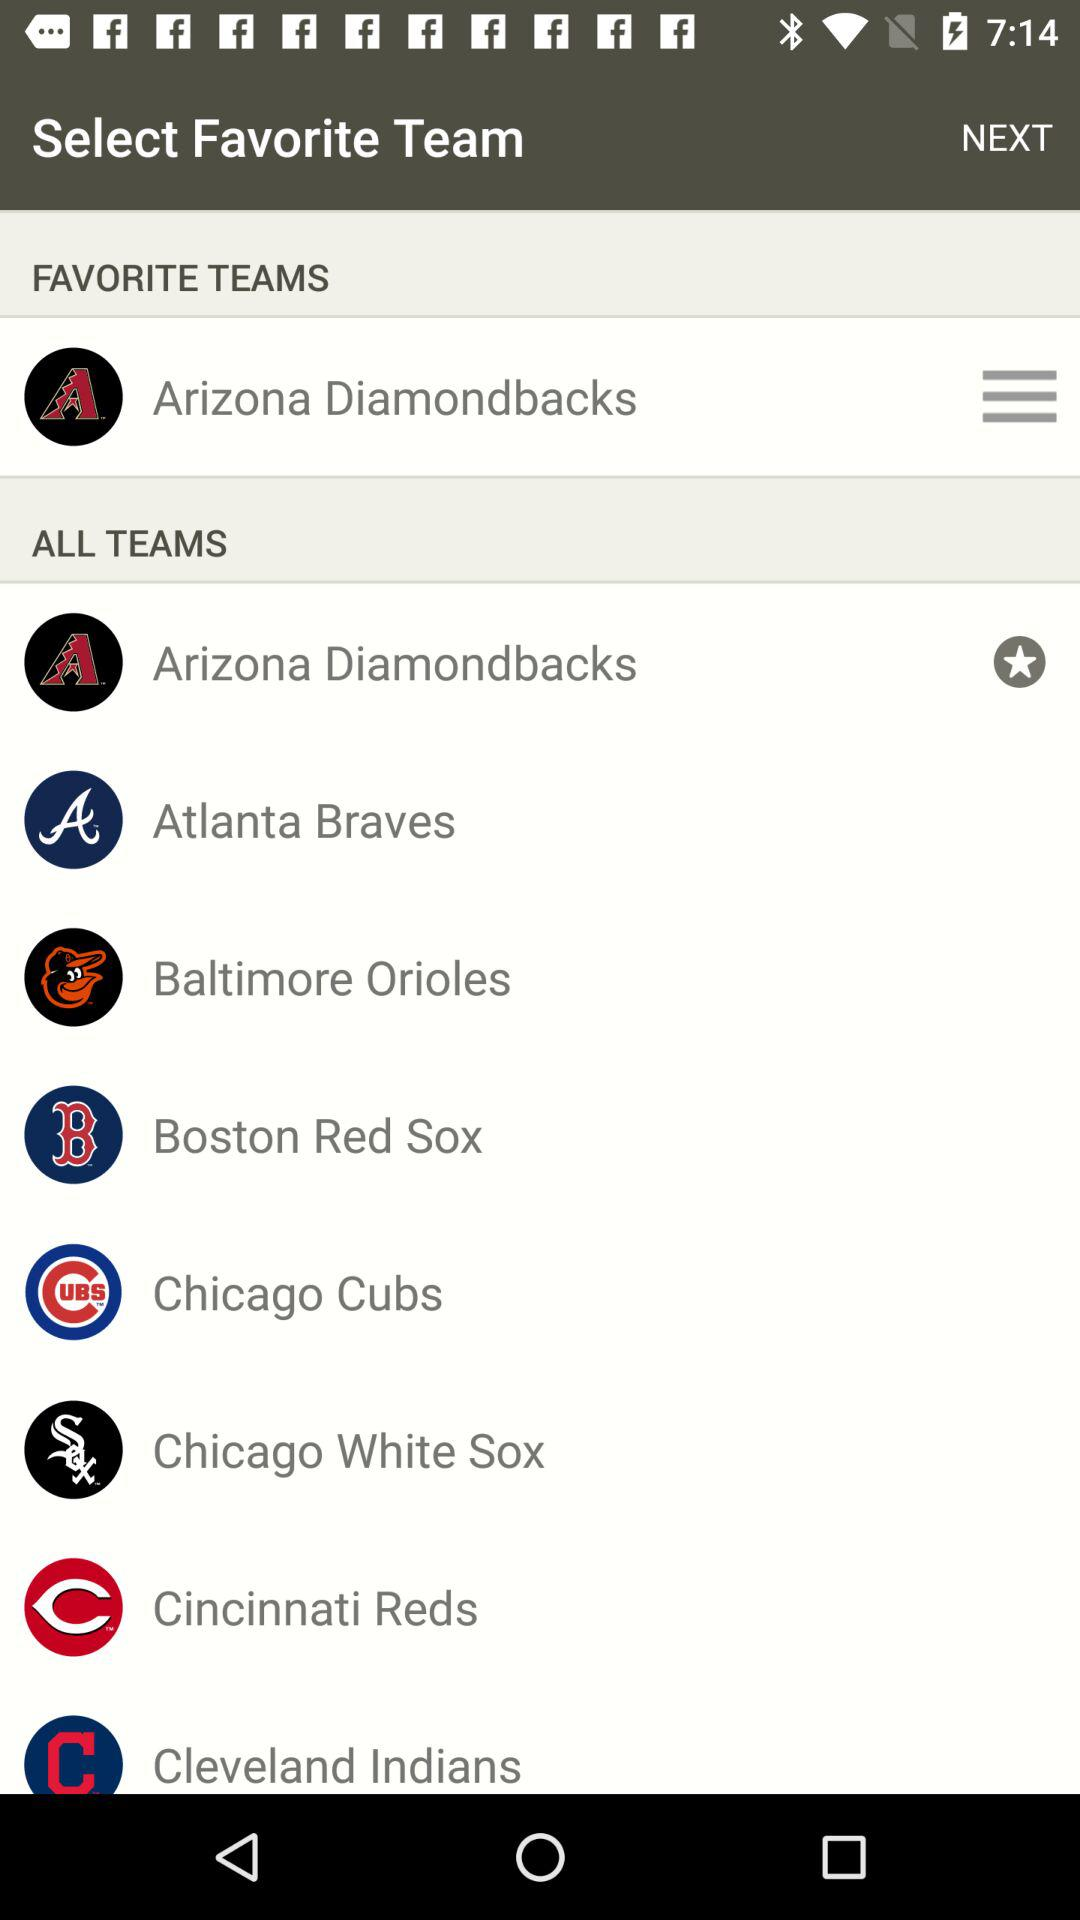What are the different favorite teams? The favorite team is "Arizona Diamondbacks". 